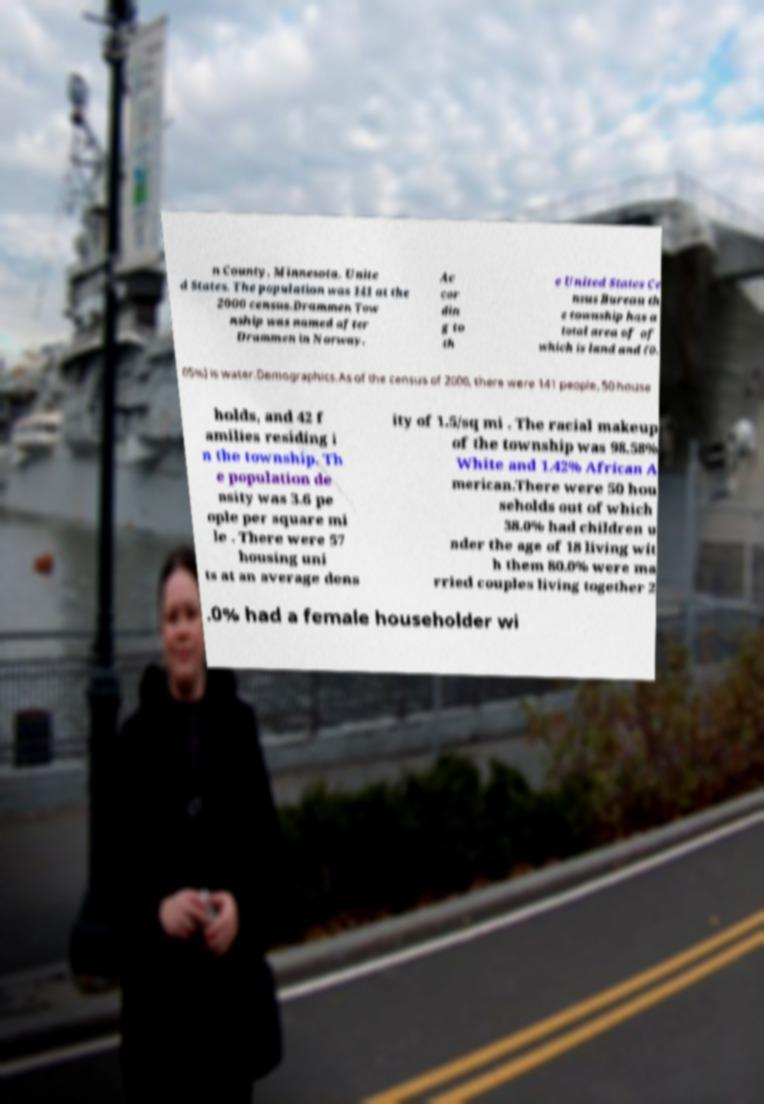Can you read and provide the text displayed in the image?This photo seems to have some interesting text. Can you extract and type it out for me? n County, Minnesota, Unite d States. The population was 141 at the 2000 census.Drammen Tow nship was named after Drammen in Norway. Ac cor din g to th e United States Ce nsus Bureau th e township has a total area of of which is land and (0. 05%) is water.Demographics.As of the census of 2000, there were 141 people, 50 house holds, and 42 f amilies residing i n the township. Th e population de nsity was 3.6 pe ople per square mi le . There were 57 housing uni ts at an average dens ity of 1.5/sq mi . The racial makeup of the township was 98.58% White and 1.42% African A merican.There were 50 hou seholds out of which 38.0% had children u nder the age of 18 living wit h them 80.0% were ma rried couples living together 2 .0% had a female householder wi 